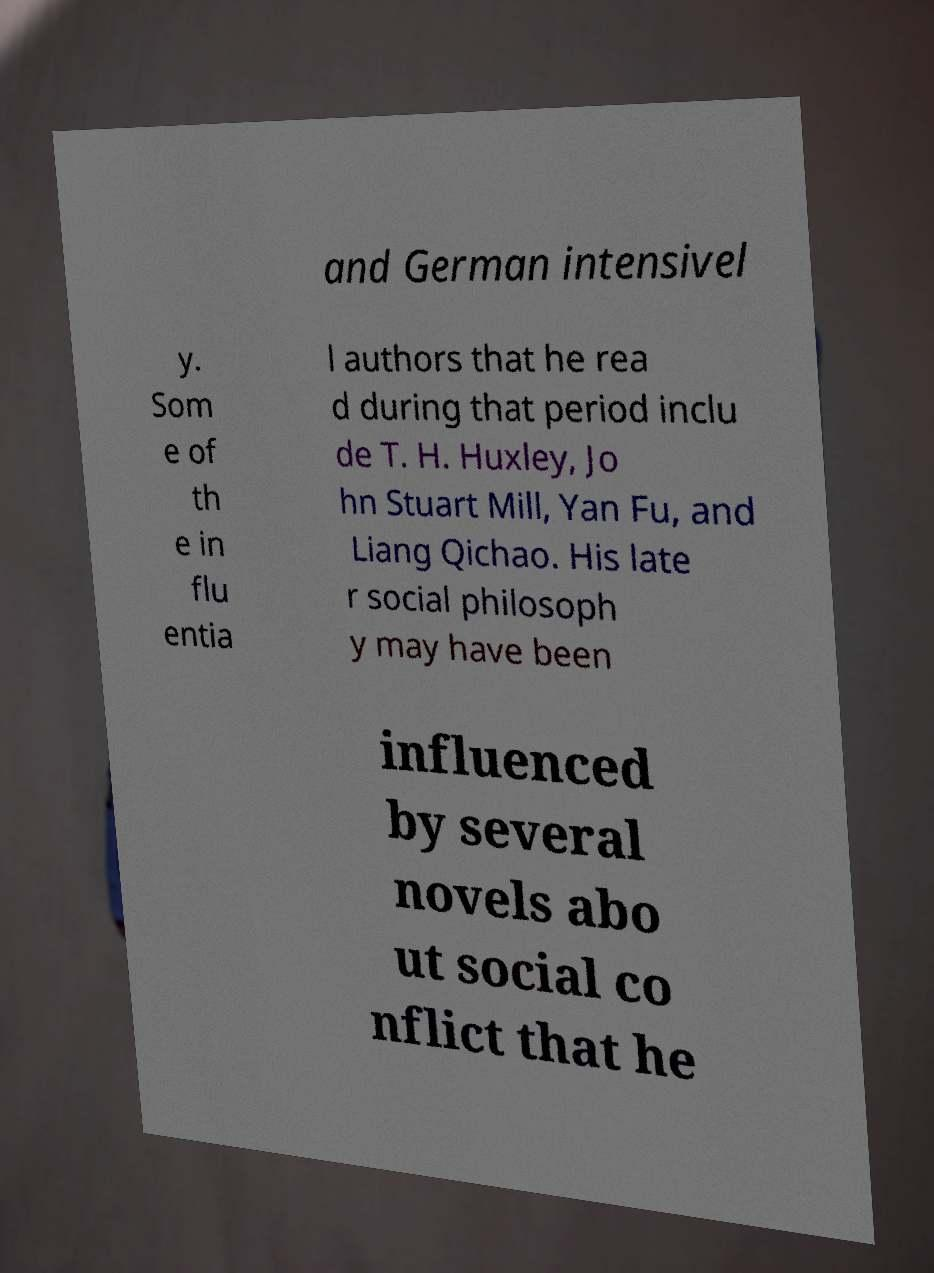Please read and relay the text visible in this image. What does it say? and German intensivel y. Som e of th e in flu entia l authors that he rea d during that period inclu de T. H. Huxley, Jo hn Stuart Mill, Yan Fu, and Liang Qichao. His late r social philosoph y may have been influenced by several novels abo ut social co nflict that he 